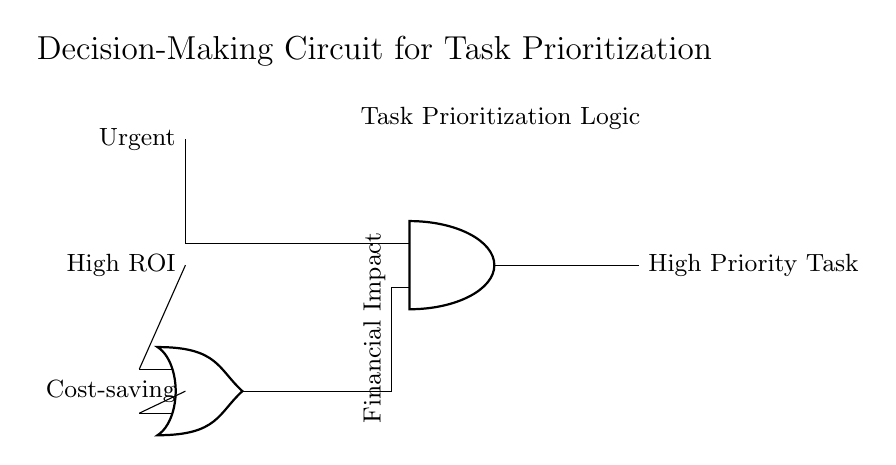What types of gates are used in the circuit? The circuit uses an OR gate and an AND gate. These gates are responsible for taking input signals and producing a single output based on their logic functions.
Answer: OR and AND How many inputs does the OR gate have? The OR gate in the circuit has two inputs, which are connected to the "High ROI" and "Cost-saving" signals. This configuration allows the OR gate to output a high signal if at least one input is high.
Answer: Two What is the purpose of the AND gate in this circuit? The AND gate is used for task prioritization. It requires one input (from the OR gate) to be high and the other input (from the "Urgent" signal) to be high in order to output a high priority task.
Answer: Task prioritization What happens when none of the input signals are high? When none of the input signals are high (that is, Urgent, High ROI, and Cost-saving are all low), the output of the AND gate will be low, indicating that there is no high priority task to consider.
Answer: No high priority task Which input directly influences the output of the AND gate? The output of the AND gate is directly influenced by the "Urgent" input signal, which must be high for the AND gate to produce a high output along with the OR gate output.
Answer: Urgent 